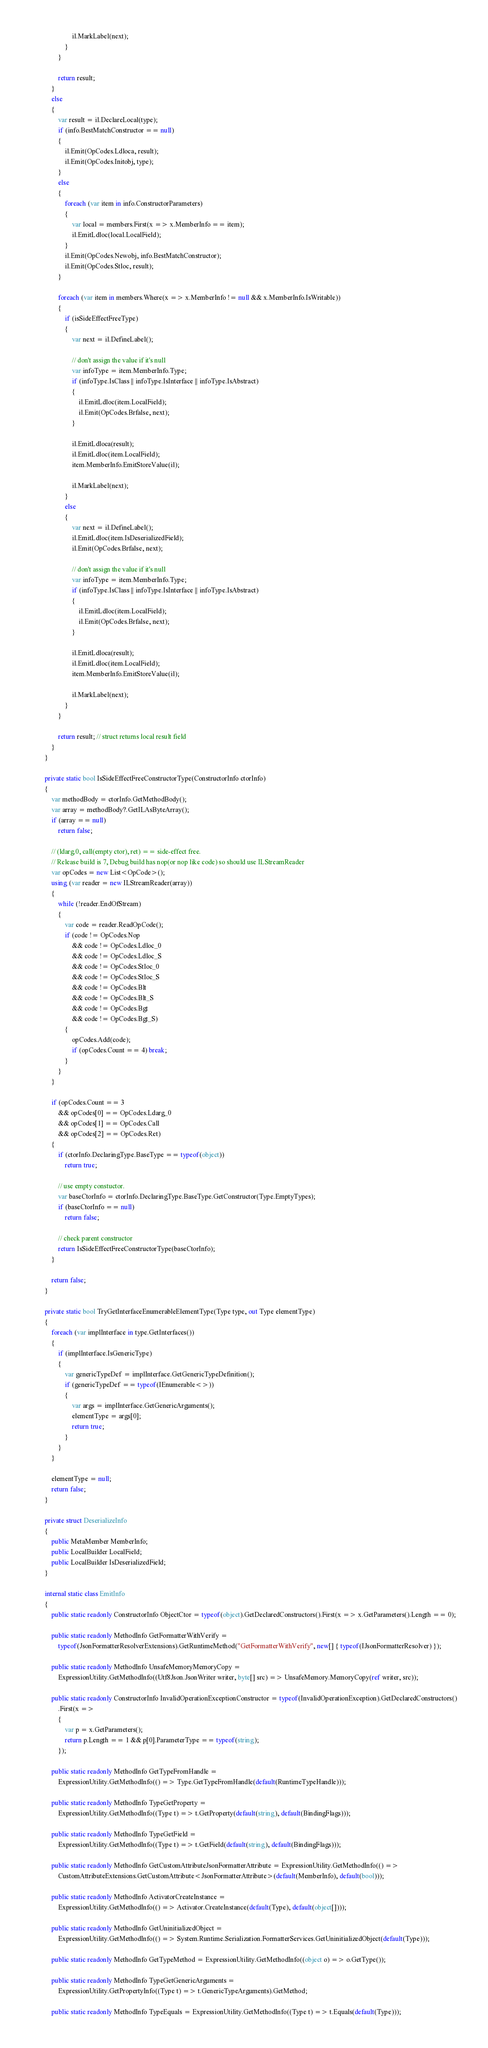<code> <loc_0><loc_0><loc_500><loc_500><_C#_>
						il.MarkLabel(next);
					}
				}

				return result;
			}
			else
			{
				var result = il.DeclareLocal(type);
				if (info.BestMatchConstructor == null)
				{
					il.Emit(OpCodes.Ldloca, result);
					il.Emit(OpCodes.Initobj, type);
				}
				else
				{
					foreach (var item in info.ConstructorParameters)
					{
						var local = members.First(x => x.MemberInfo == item);
						il.EmitLdloc(local.LocalField);
					}
					il.Emit(OpCodes.Newobj, info.BestMatchConstructor);
					il.Emit(OpCodes.Stloc, result);
				}

				foreach (var item in members.Where(x => x.MemberInfo != null && x.MemberInfo.IsWritable))
				{
					if (isSideEffectFreeType)
					{
						var next = il.DefineLabel();

						// don't assign the value if it's null
						var infoType = item.MemberInfo.Type;
						if (infoType.IsClass || infoType.IsInterface || infoType.IsAbstract)
						{
							il.EmitLdloc(item.LocalField);
							il.Emit(OpCodes.Brfalse, next);
						}

						il.EmitLdloca(result);
						il.EmitLdloc(item.LocalField);
						item.MemberInfo.EmitStoreValue(il);

						il.MarkLabel(next);
					}
					else
					{
						var next = il.DefineLabel();
						il.EmitLdloc(item.IsDeserializedField);
						il.Emit(OpCodes.Brfalse, next);

						// don't assign the value if it's null
						var infoType = item.MemberInfo.Type;
						if (infoType.IsClass || infoType.IsInterface || infoType.IsAbstract)
						{
							il.EmitLdloc(item.LocalField);
							il.Emit(OpCodes.Brfalse, next);
						}

						il.EmitLdloca(result);
						il.EmitLdloc(item.LocalField);
						item.MemberInfo.EmitStoreValue(il);

						il.MarkLabel(next);
					}
				}

				return result; // struct returns local result field
			}
		}

		private static bool IsSideEffectFreeConstructorType(ConstructorInfo ctorInfo)
		{
			var methodBody = ctorInfo.GetMethodBody();
			var array = methodBody?.GetILAsByteArray();
			if (array == null)
				return false;

			// (ldarg.0, call(empty ctor), ret) == side-effect free.
			// Release build is 7, Debug build has nop(or nop like code) so should use ILStreamReader
			var opCodes = new List<OpCode>();
			using (var reader = new ILStreamReader(array))
			{
				while (!reader.EndOfStream)
				{
					var code = reader.ReadOpCode();
					if (code != OpCodes.Nop
						&& code != OpCodes.Ldloc_0
						&& code != OpCodes.Ldloc_S
						&& code != OpCodes.Stloc_0
						&& code != OpCodes.Stloc_S
						&& code != OpCodes.Blt
						&& code != OpCodes.Blt_S
						&& code != OpCodes.Bgt
						&& code != OpCodes.Bgt_S)
					{
						opCodes.Add(code);
						if (opCodes.Count == 4) break;
					}
				}
			}

			if (opCodes.Count == 3
				&& opCodes[0] == OpCodes.Ldarg_0
				&& opCodes[1] == OpCodes.Call
				&& opCodes[2] == OpCodes.Ret)
			{
				if (ctorInfo.DeclaringType.BaseType == typeof(object))
					return true;

				// use empty constuctor.
				var baseCtorInfo = ctorInfo.DeclaringType.BaseType.GetConstructor(Type.EmptyTypes);
				if (baseCtorInfo == null)
					return false;

				// check parent constructor
				return IsSideEffectFreeConstructorType(baseCtorInfo);
			}

			return false;
		}

		private static bool TryGetInterfaceEnumerableElementType(Type type, out Type elementType)
		{
			foreach (var implInterface in type.GetInterfaces())
			{
				if (implInterface.IsGenericType)
				{
					var genericTypeDef = implInterface.GetGenericTypeDefinition();
					if (genericTypeDef == typeof(IEnumerable<>))
					{
						var args = implInterface.GetGenericArguments();
						elementType = args[0];
						return true;
					}
				}
			}

			elementType = null;
			return false;
		}

		private struct DeserializeInfo
		{
			public MetaMember MemberInfo;
			public LocalBuilder LocalField;
			public LocalBuilder IsDeserializedField;
		}

		internal static class EmitInfo
		{
			public static readonly ConstructorInfo ObjectCtor = typeof(object).GetDeclaredConstructors().First(x => x.GetParameters().Length == 0);

			public static readonly MethodInfo GetFormatterWithVerify =
				typeof(JsonFormatterResolverExtensions).GetRuntimeMethod("GetFormatterWithVerify", new[] { typeof(IJsonFormatterResolver) });

			public static readonly MethodInfo UnsafeMemoryMemoryCopy =
				ExpressionUtility.GetMethodInfo((Utf8Json.JsonWriter writer, byte[] src) => UnsafeMemory.MemoryCopy(ref writer, src));

			public static readonly ConstructorInfo InvalidOperationExceptionConstructor = typeof(InvalidOperationException).GetDeclaredConstructors()
				.First(x =>
				{
					var p = x.GetParameters();
					return p.Length == 1 && p[0].ParameterType == typeof(string);
				});

			public static readonly MethodInfo GetTypeFromHandle =
				ExpressionUtility.GetMethodInfo(() => Type.GetTypeFromHandle(default(RuntimeTypeHandle)));

			public static readonly MethodInfo TypeGetProperty =
				ExpressionUtility.GetMethodInfo((Type t) => t.GetProperty(default(string), default(BindingFlags)));

			public static readonly MethodInfo TypeGetField =
				ExpressionUtility.GetMethodInfo((Type t) => t.GetField(default(string), default(BindingFlags)));

			public static readonly MethodInfo GetCustomAttributeJsonFormatterAttribute = ExpressionUtility.GetMethodInfo(() =>
				CustomAttributeExtensions.GetCustomAttribute<JsonFormatterAttribute>(default(MemberInfo), default(bool)));

			public static readonly MethodInfo ActivatorCreateInstance =
				ExpressionUtility.GetMethodInfo(() => Activator.CreateInstance(default(Type), default(object[])));

			public static readonly MethodInfo GetUninitializedObject =
				ExpressionUtility.GetMethodInfo(() => System.Runtime.Serialization.FormatterServices.GetUninitializedObject(default(Type)));

			public static readonly MethodInfo GetTypeMethod = ExpressionUtility.GetMethodInfo((object o) => o.GetType());

			public static readonly MethodInfo TypeGetGenericArguments =
				ExpressionUtility.GetPropertyInfo((Type t) => t.GenericTypeArguments).GetMethod;

			public static readonly MethodInfo TypeEquals = ExpressionUtility.GetMethodInfo((Type t) => t.Equals(default(Type)));
</code> 